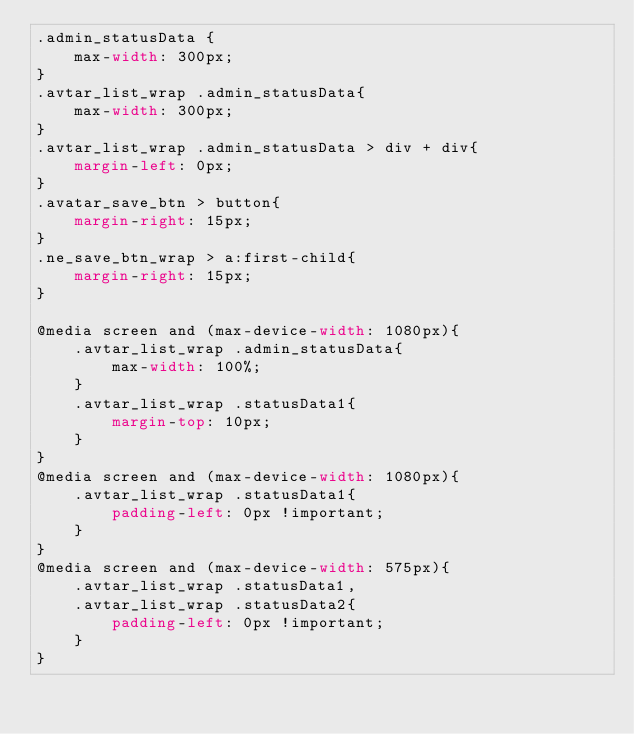<code> <loc_0><loc_0><loc_500><loc_500><_CSS_>.admin_statusData {
    max-width: 300px;
}
.avtar_list_wrap .admin_statusData{
    max-width: 300px;
}
.avtar_list_wrap .admin_statusData > div + div{
    margin-left: 0px;
}
.avatar_save_btn > button{
    margin-right: 15px;
}
.ne_save_btn_wrap > a:first-child{
    margin-right: 15px;
}

@media screen and (max-device-width: 1080px){
    .avtar_list_wrap .admin_statusData{
        max-width: 100%;
    }
    .avtar_list_wrap .statusData1{
        margin-top: 10px;
    }
}
@media screen and (max-device-width: 1080px){
    .avtar_list_wrap .statusData1{
        padding-left: 0px !important;
    }
}
@media screen and (max-device-width: 575px){
    .avtar_list_wrap .statusData1,
    .avtar_list_wrap .statusData2{
        padding-left: 0px !important;
    }
}</code> 